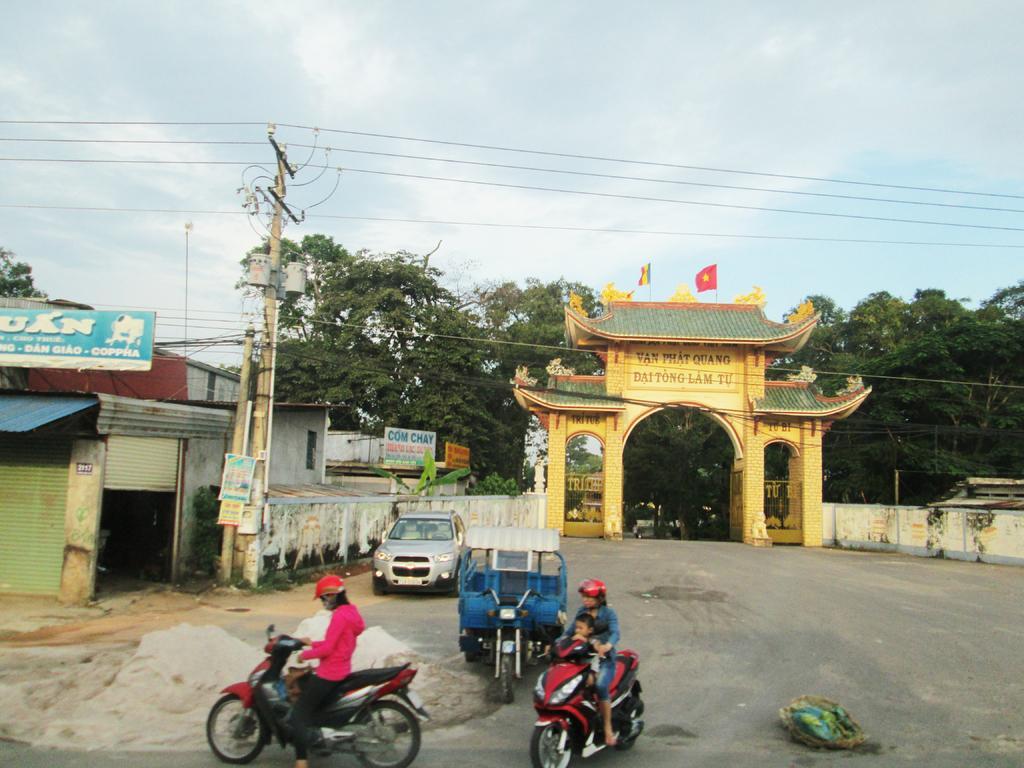Can you describe this image briefly? In this image in the center there are persons riding a bike and there are vehicles on the road. In the background there are trees, there are boards with some text written on it, there are shutters and there is an arch, on the top of the arch, there are flags and the sky is cloudy and there are wires. 